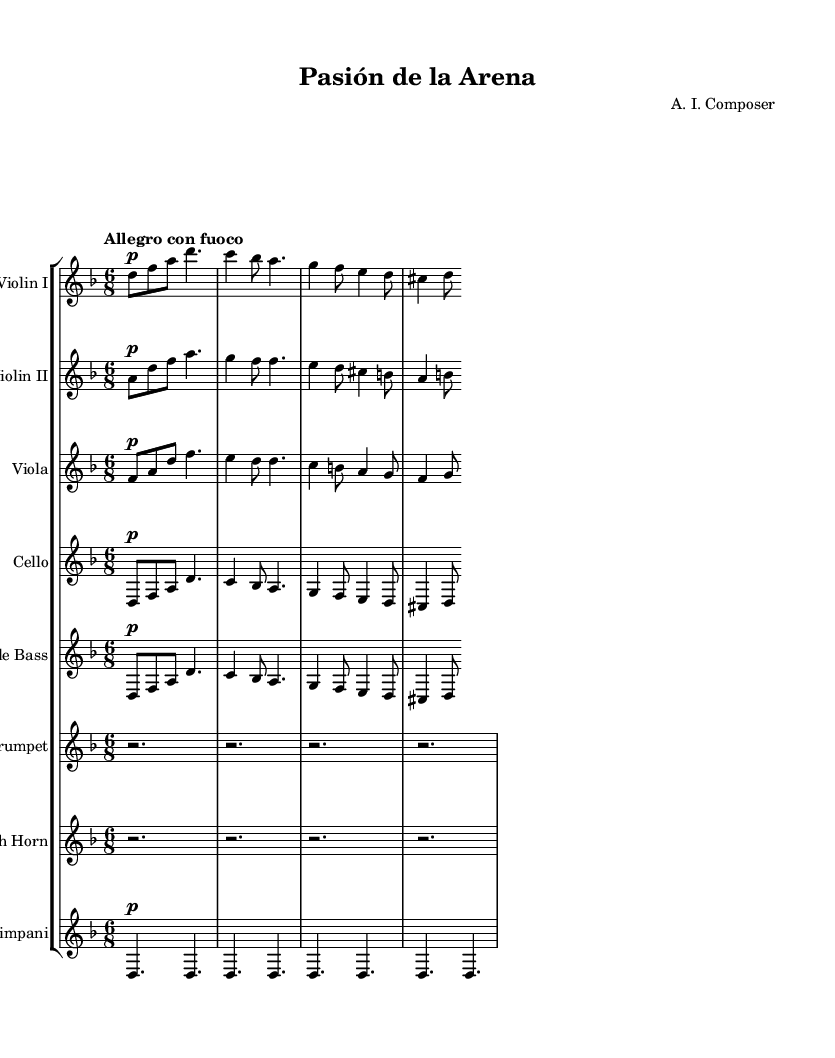What is the key signature of this music? The key signature is indicated at the beginning and denotes D minor, which includes one flat (B).
Answer: D minor What is the time signature of the piece? The time signature is stated at the beginning of the score. It shows 6/8, meaning there are six eighth notes per measure.
Answer: 6/8 What is the tempo marking for this piece? The tempo marking is provided in Italian, and it indicates the speed of the piece. It is labeled "Allegro con fuoco," suggesting a fast tempo with a fiery intensity.
Answer: Allegro con fuoco How many staves are presented in this score? To determine this, I count the number of staves in the score grouping. There are eight different staves for various instruments listed.
Answer: Eight What is the primary instrument group for this composition? Looking at the instruments listed at the beginning of the score, the majority of them belong to the string family.
Answer: Strings Which instruments have the same musical lines in the score? By examining the staves, I see that the violin parts (Violin I and Violin II) have similar rhythmic and melodic features, indicating they often play together.
Answer: Violin I and Violin II What type of mood does this piece convey based on the markings? Analyzing the tempo and dynamics throughout the score, "Allegro con fuoco" coupled with the intensity of the written lines suggests a dramatic and aggressive mood, fitting to depict the intensity of a bullfight.
Answer: Dramatic 